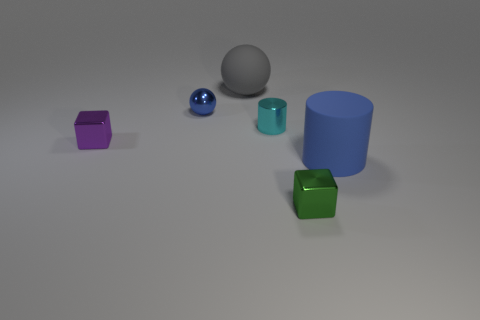There is a matte cylinder that is the same color as the shiny sphere; what size is it?
Offer a very short reply. Large. Does the blue shiny object have the same shape as the purple metal object?
Provide a short and direct response. No. What number of small purple cubes are on the right side of the shiny thing that is on the left side of the blue metallic sphere?
Your answer should be very brief. 0. What material is the other object that is the same shape as the purple shiny thing?
Provide a succinct answer. Metal. There is a metal cube on the left side of the small cyan shiny cylinder; does it have the same color as the small sphere?
Keep it short and to the point. No. Does the purple thing have the same material as the blue thing that is behind the big blue rubber object?
Provide a short and direct response. Yes. The big thing behind the small purple block has what shape?
Provide a succinct answer. Sphere. What number of other things are there of the same material as the tiny ball
Give a very brief answer. 3. The cyan cylinder is what size?
Offer a very short reply. Small. What number of other things are there of the same color as the shiny cylinder?
Provide a succinct answer. 0. 